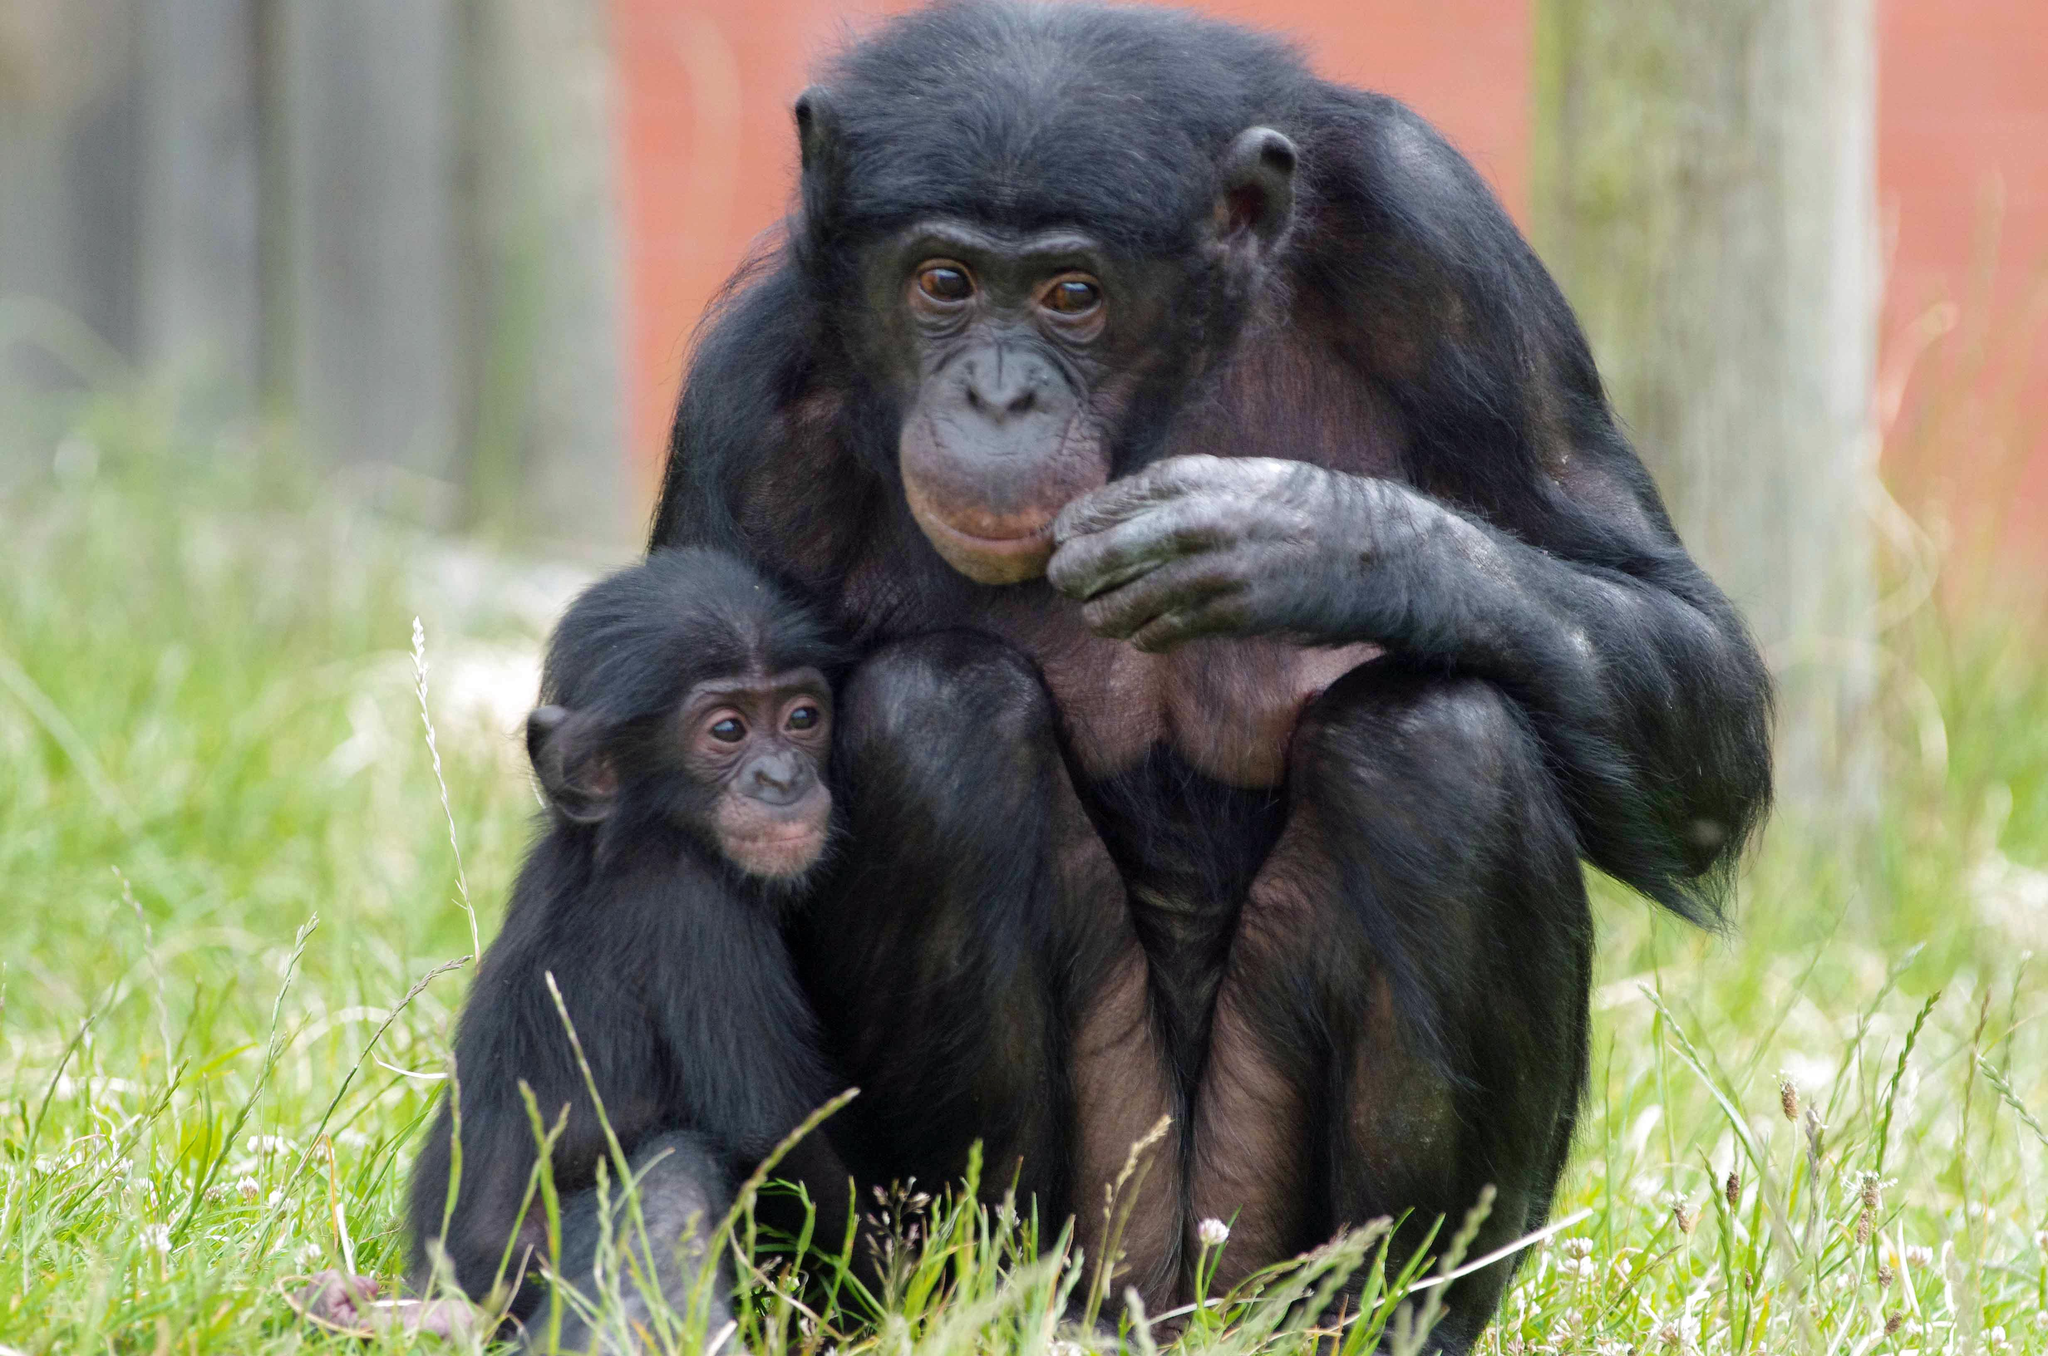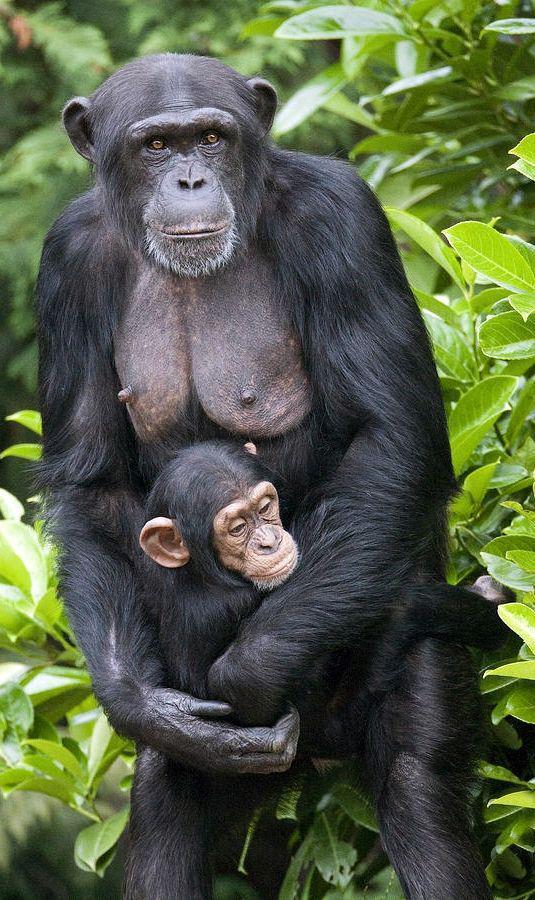The first image is the image on the left, the second image is the image on the right. Analyze the images presented: Is the assertion "There is a baby monkey cuddling its mother in one of the images." valid? Answer yes or no. Yes. 